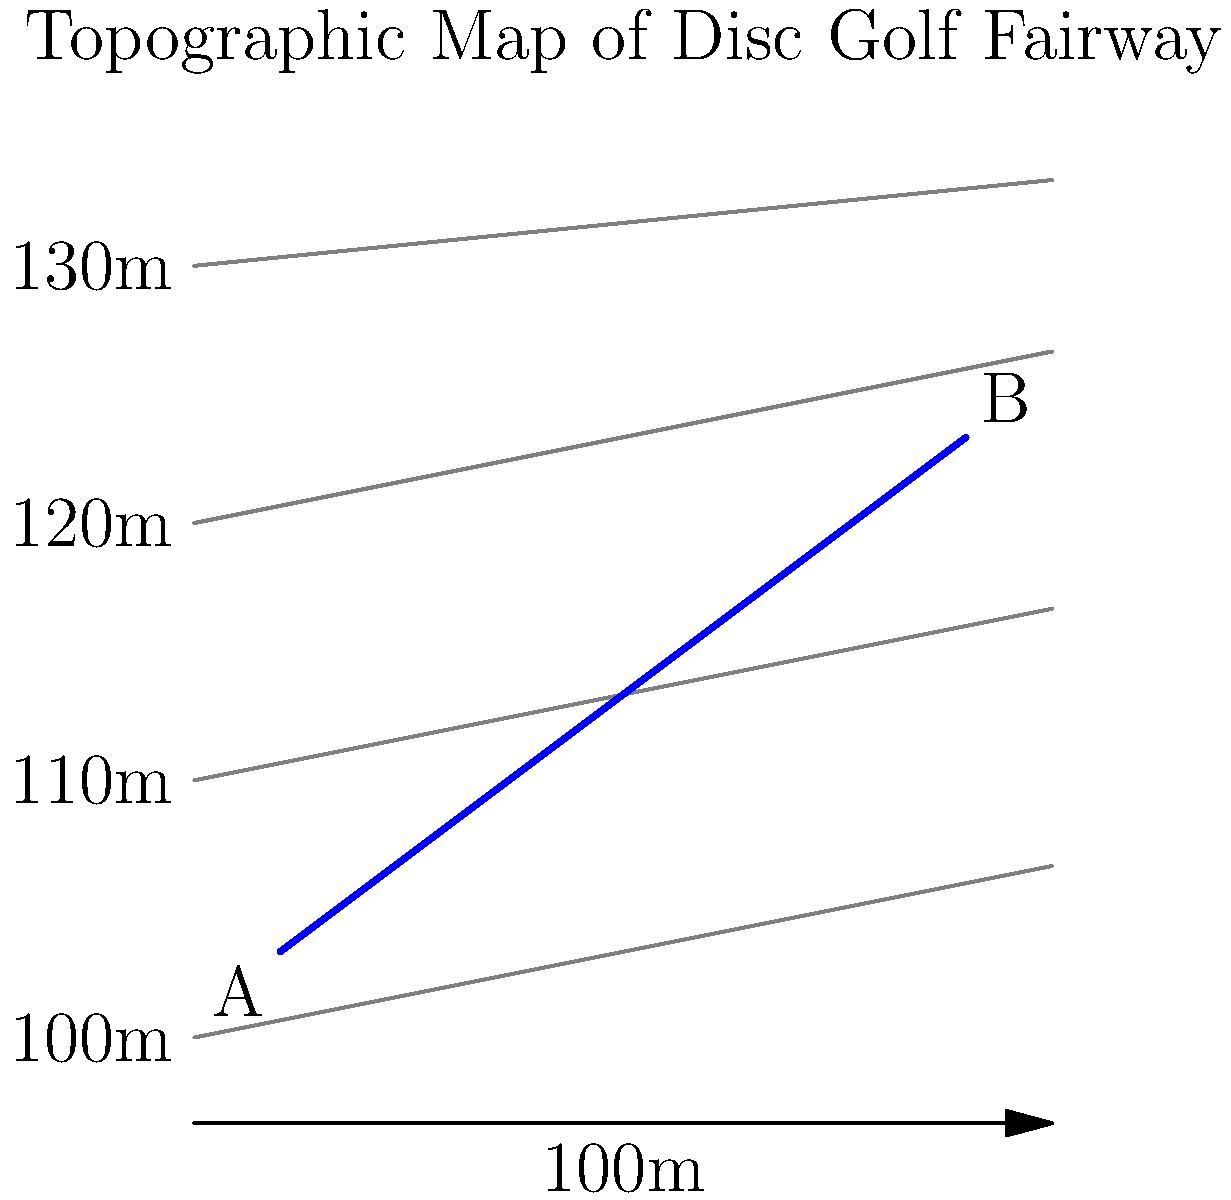As a community organizer planning a disc golf tournament, you need to calculate the optimal slope for a fairway. Using the provided topographic map, determine the average slope of the fairway between points A and B. The fairway is represented by the blue line, and each contour line represents a 10-meter elevation change. What is the average slope as a percentage? To calculate the average slope of the fairway, we need to follow these steps:

1. Determine the horizontal distance between points A and B:
   - The scale shows 100m for the full width of the map
   - The fairway (blue line) covers about 80% of the map width
   - Horizontal distance = $100m \times 0.80 = 80m$

2. Determine the vertical elevation change between points A and B:
   - Point A is slightly above the 100m contour line
   - Point B is between the 120m and 130m contour lines, approximately at 125m
   - Elevation change = $125m - 100m = 25m$

3. Calculate the slope using the formula:
   $\text{Slope} = \frac{\text{Rise}}{\text{Run}} \times 100\%$

   Where:
   - Rise = Vertical elevation change = 25m
   - Run = Horizontal distance = 80m

   $\text{Slope} = \frac{25m}{80m} \times 100\% = 0.3125 \times 100\% = 31.25\%$

Therefore, the average slope of the fairway is 31.25%.
Answer: 31.25% 